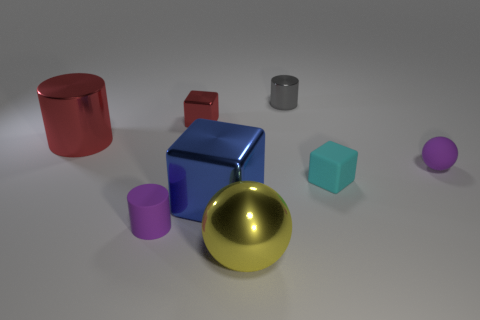Does the tiny cylinder left of the yellow metallic object have the same color as the matte sphere?
Offer a very short reply. Yes. Are there any tiny purple matte things in front of the small matte block?
Give a very brief answer. Yes. There is a tiny object that is both behind the small cyan matte block and right of the tiny gray shiny thing; what color is it?
Provide a short and direct response. Purple. The big shiny object that is the same color as the tiny metal block is what shape?
Make the answer very short. Cylinder. How big is the metal block that is in front of the red thing behind the large red metallic thing?
Provide a short and direct response. Large. What number of cubes are tiny gray things or small green metal things?
Ensure brevity in your answer.  0. There is a cylinder that is the same size as the blue metal object; what color is it?
Provide a short and direct response. Red. The tiny purple object that is behind the tiny rubber object that is on the left side of the tiny gray metallic cylinder is what shape?
Make the answer very short. Sphere. There is a ball behind the yellow sphere; is it the same size as the gray thing?
Ensure brevity in your answer.  Yes. What number of other objects are the same material as the gray cylinder?
Provide a succinct answer. 4. 